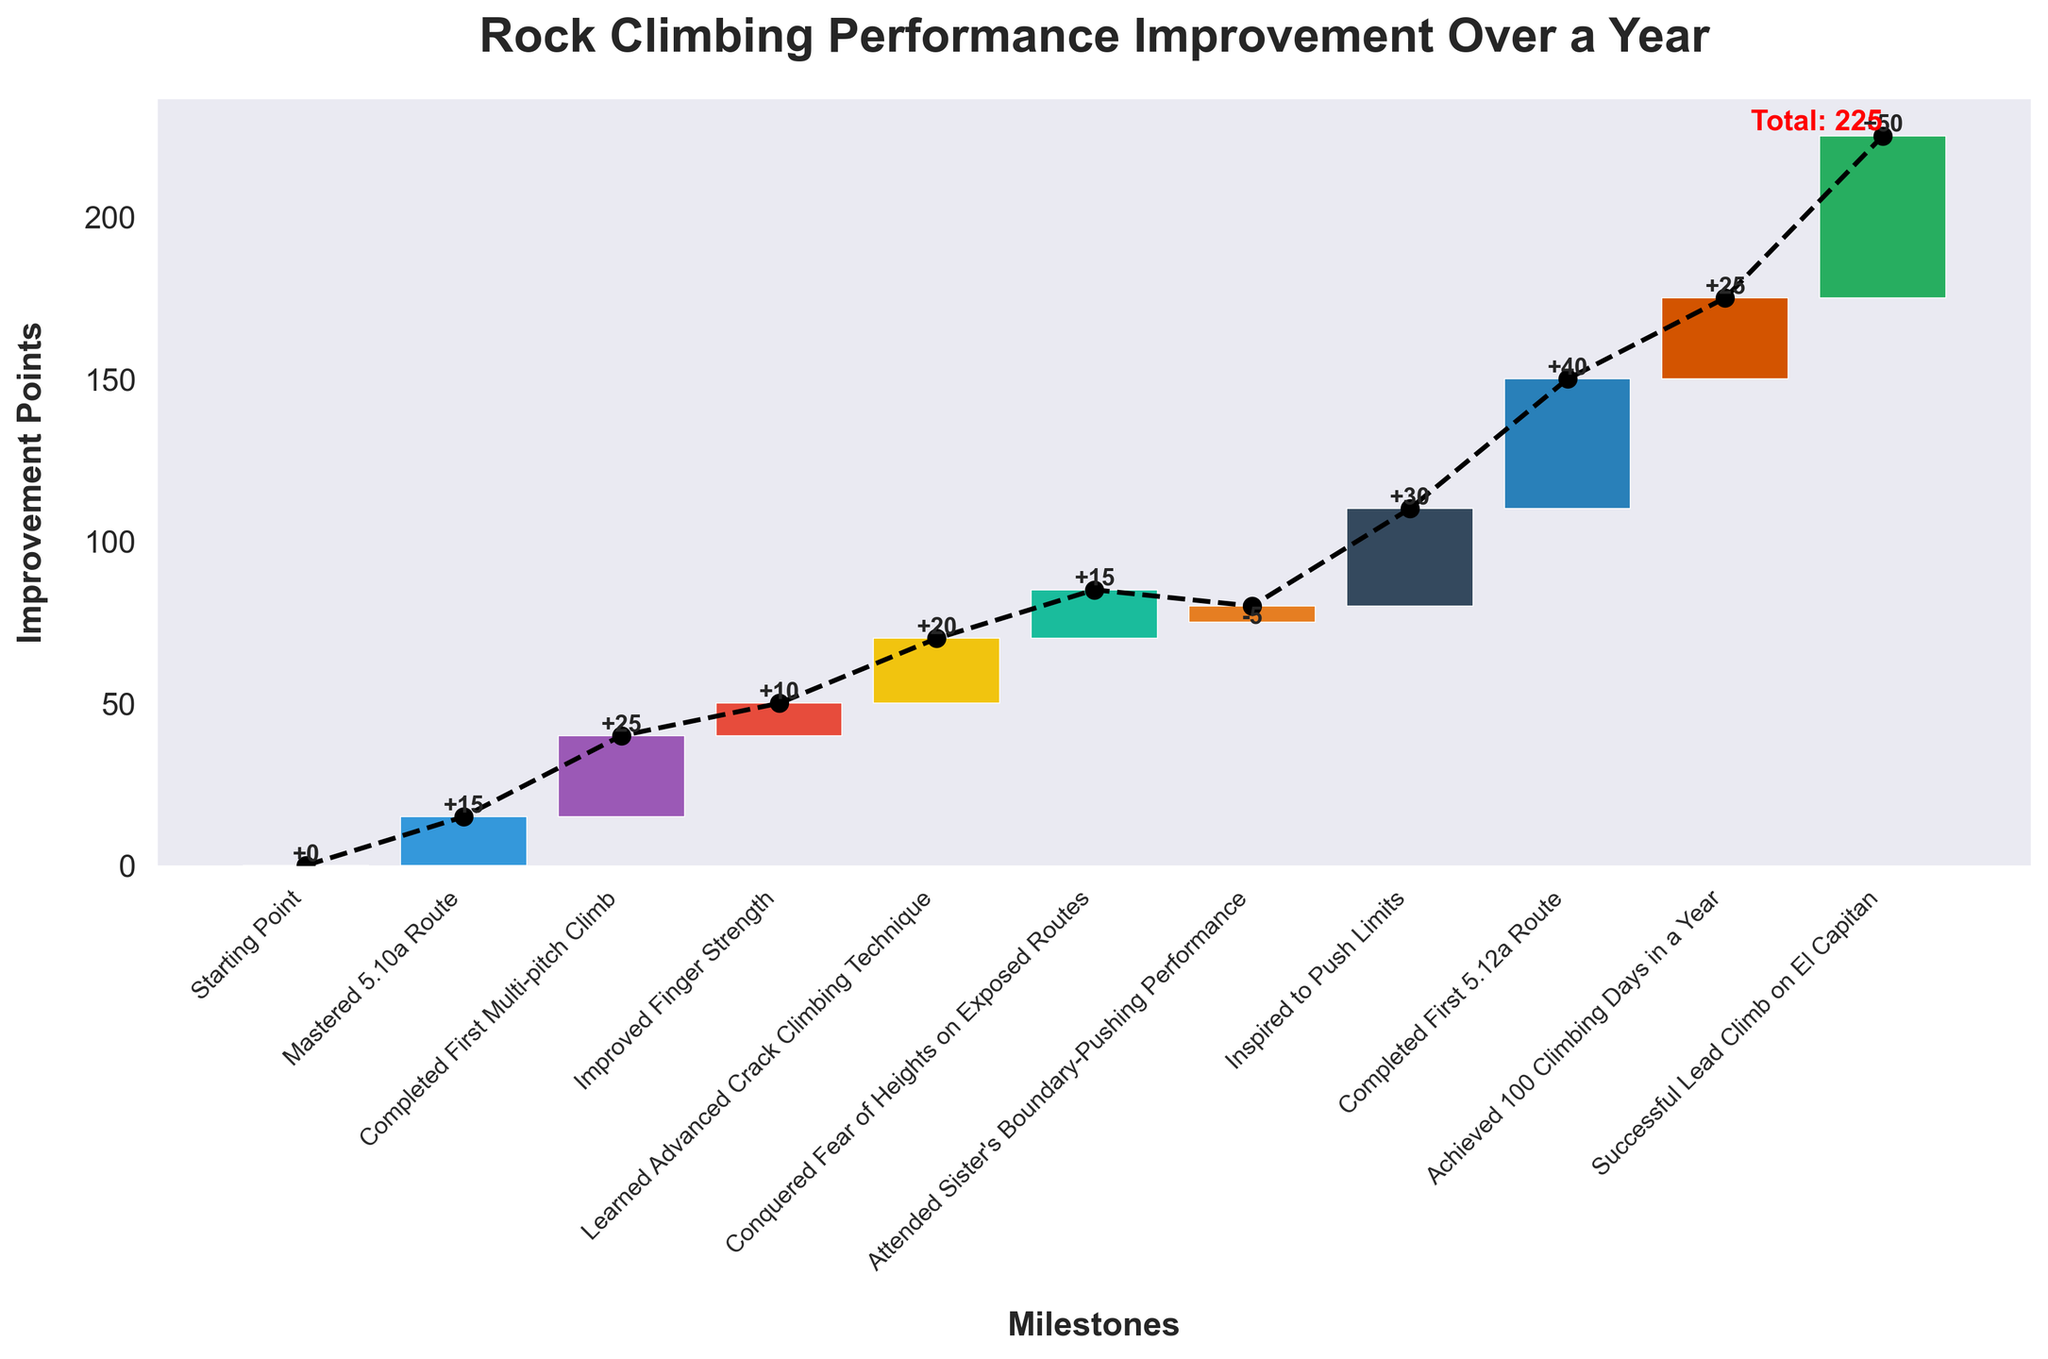How much improvement points were gained from mastering the 5.10a route? Look at the bar labeled "Mastered 5.10a Route" and refer to its associated value, which is the improvement points gained.
Answer: 15 What is the cumulative improvement after learning the advanced crack climbing technique? Observe the cumulative line plotted on the chart and identify the cumulative points after the "Learned Advanced Crack Climbing Technique" milestone. By following the connecting line or bottom label, you can see the cumulative value.
Answer: 70 Which milestone had the highest single improvement value? Compare the heights of all the individual bars to find the tallest one. The "Successful Lead Climb on El Capitan" bar is the tallest, indicating it had the highest single improvement value.
Answer: Successful Lead Climb on El Capitan What is the total improvement at the end of the year? Look at the final value or the text labeled "Total Improvement" on the chart.
Answer: 225 How did attending your sister's boundary-pushing performance affect your improvement trajectory? Look for the bar related to "Attended Sister's Boundary-Pushing Performance." Note that it points downwards, indicating a decrease of 5 in the cumulative improvement.
Answer: Decreased by 5 How many milestones had a positive impact (increase) on your performance? Count the number of bars that point upwards, indicating an increase in improvement points.
Answer: 9 Which milestone directly follows "Improved Finger Strength," and what impact did it have? Identify the milestone labeled "Improved Finger Strength," then look at the next milestone on the x-axis, which is "Learned Advanced Crack Climbing Technique." Refer to the value associated with it to determine its impact.
Answer: Learned Advanced Crack Climbing Technique, +20 Compare the combined improvement from "Completed First Multi-pitch Climb" and "Conquered Fear of Heights on Exposed Routes" to the improvement from "Completed First 5.12a Route." Which is greater? Add the improvements from "Completed First Multi-pitch Climb" (25) and "Conquered Fear of Heights on Exposed Routes" (15) to get a combined total of 40. Compare this to the "Completed First 5.12a Route" value of 40, noting they are equal.
Answer: Equal How much of the total improvement is achieved prior to the "Inspired to Push Limits" milestone? Calculate the cumulative improvement up to the milestone "Inspired to Push Limits" by summing all previous values: 15 (Mastered 5.10a Route), 25 (Completed First Multi-pitch Climb), 10 (Improved Finger Strength), 20 (Learned Advanced Crack Climbing Technique), 15 (Conquered Fear of Heights on Exposed Routes), subtract 5 (Attended Sister's Boundary-Pushing Performance). Total is 80.
Answer: 80 